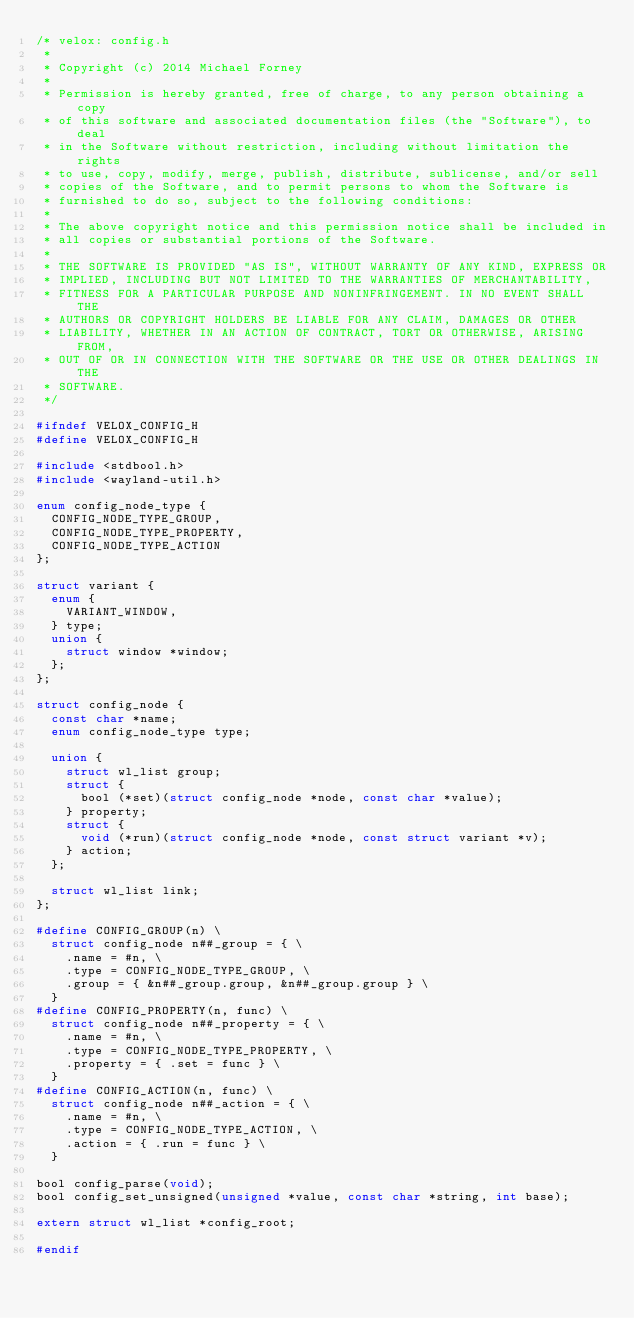Convert code to text. <code><loc_0><loc_0><loc_500><loc_500><_C_>/* velox: config.h
 *
 * Copyright (c) 2014 Michael Forney
 *
 * Permission is hereby granted, free of charge, to any person obtaining a copy
 * of this software and associated documentation files (the "Software"), to deal
 * in the Software without restriction, including without limitation the rights
 * to use, copy, modify, merge, publish, distribute, sublicense, and/or sell
 * copies of the Software, and to permit persons to whom the Software is
 * furnished to do so, subject to the following conditions:
 *
 * The above copyright notice and this permission notice shall be included in
 * all copies or substantial portions of the Software.
 *
 * THE SOFTWARE IS PROVIDED "AS IS", WITHOUT WARRANTY OF ANY KIND, EXPRESS OR
 * IMPLIED, INCLUDING BUT NOT LIMITED TO THE WARRANTIES OF MERCHANTABILITY,
 * FITNESS FOR A PARTICULAR PURPOSE AND NONINFRINGEMENT. IN NO EVENT SHALL THE
 * AUTHORS OR COPYRIGHT HOLDERS BE LIABLE FOR ANY CLAIM, DAMAGES OR OTHER
 * LIABILITY, WHETHER IN AN ACTION OF CONTRACT, TORT OR OTHERWISE, ARISING FROM,
 * OUT OF OR IN CONNECTION WITH THE SOFTWARE OR THE USE OR OTHER DEALINGS IN THE
 * SOFTWARE.
 */

#ifndef VELOX_CONFIG_H
#define VELOX_CONFIG_H

#include <stdbool.h>
#include <wayland-util.h>

enum config_node_type {
	CONFIG_NODE_TYPE_GROUP,
	CONFIG_NODE_TYPE_PROPERTY,
	CONFIG_NODE_TYPE_ACTION
};

struct variant {
	enum {
		VARIANT_WINDOW,
	} type;
	union {
		struct window *window;
	};
};

struct config_node {
	const char *name;
	enum config_node_type type;

	union {
		struct wl_list group;
		struct {
			bool (*set)(struct config_node *node, const char *value);
		} property;
		struct {
			void (*run)(struct config_node *node, const struct variant *v);
		} action;
	};

	struct wl_list link;
};

#define CONFIG_GROUP(n) \
	struct config_node n##_group = { \
		.name = #n, \
		.type = CONFIG_NODE_TYPE_GROUP, \
		.group = { &n##_group.group, &n##_group.group } \
	}
#define CONFIG_PROPERTY(n, func) \
	struct config_node n##_property = { \
		.name = #n, \
		.type = CONFIG_NODE_TYPE_PROPERTY, \
		.property = { .set = func } \
	}
#define CONFIG_ACTION(n, func) \
	struct config_node n##_action = { \
		.name = #n, \
		.type = CONFIG_NODE_TYPE_ACTION, \
		.action = { .run = func } \
	}

bool config_parse(void);
bool config_set_unsigned(unsigned *value, const char *string, int base);

extern struct wl_list *config_root;

#endif
</code> 